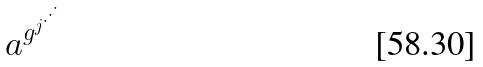<formula> <loc_0><loc_0><loc_500><loc_500>a ^ { g ^ { j ^ { \cdot ^ { \cdot ^ { \cdot } } } } }</formula> 